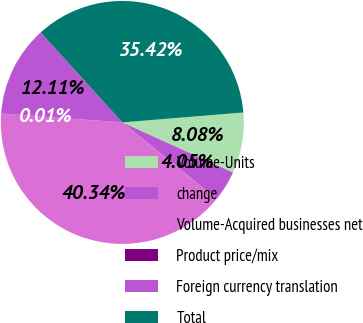<chart> <loc_0><loc_0><loc_500><loc_500><pie_chart><fcel>Volume-Units<fcel>change<fcel>Volume-Acquired businesses net<fcel>Product price/mix<fcel>Foreign currency translation<fcel>Total<nl><fcel>8.08%<fcel>4.05%<fcel>40.34%<fcel>0.01%<fcel>12.11%<fcel>35.42%<nl></chart> 